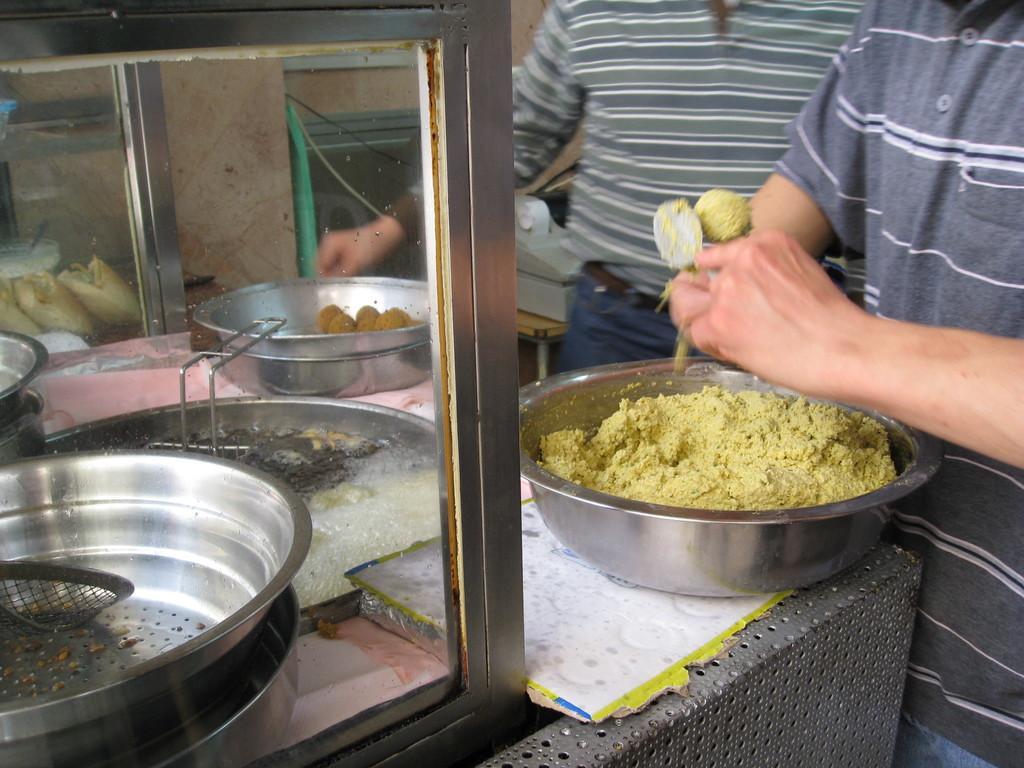Describe this image in one or two sentences. In this image there are two men on the right side who are making the food with the floor. On the left side there is a glass door. Beside the glass door there are vessels,bowls and some food items. It seems like a cooking stove. 